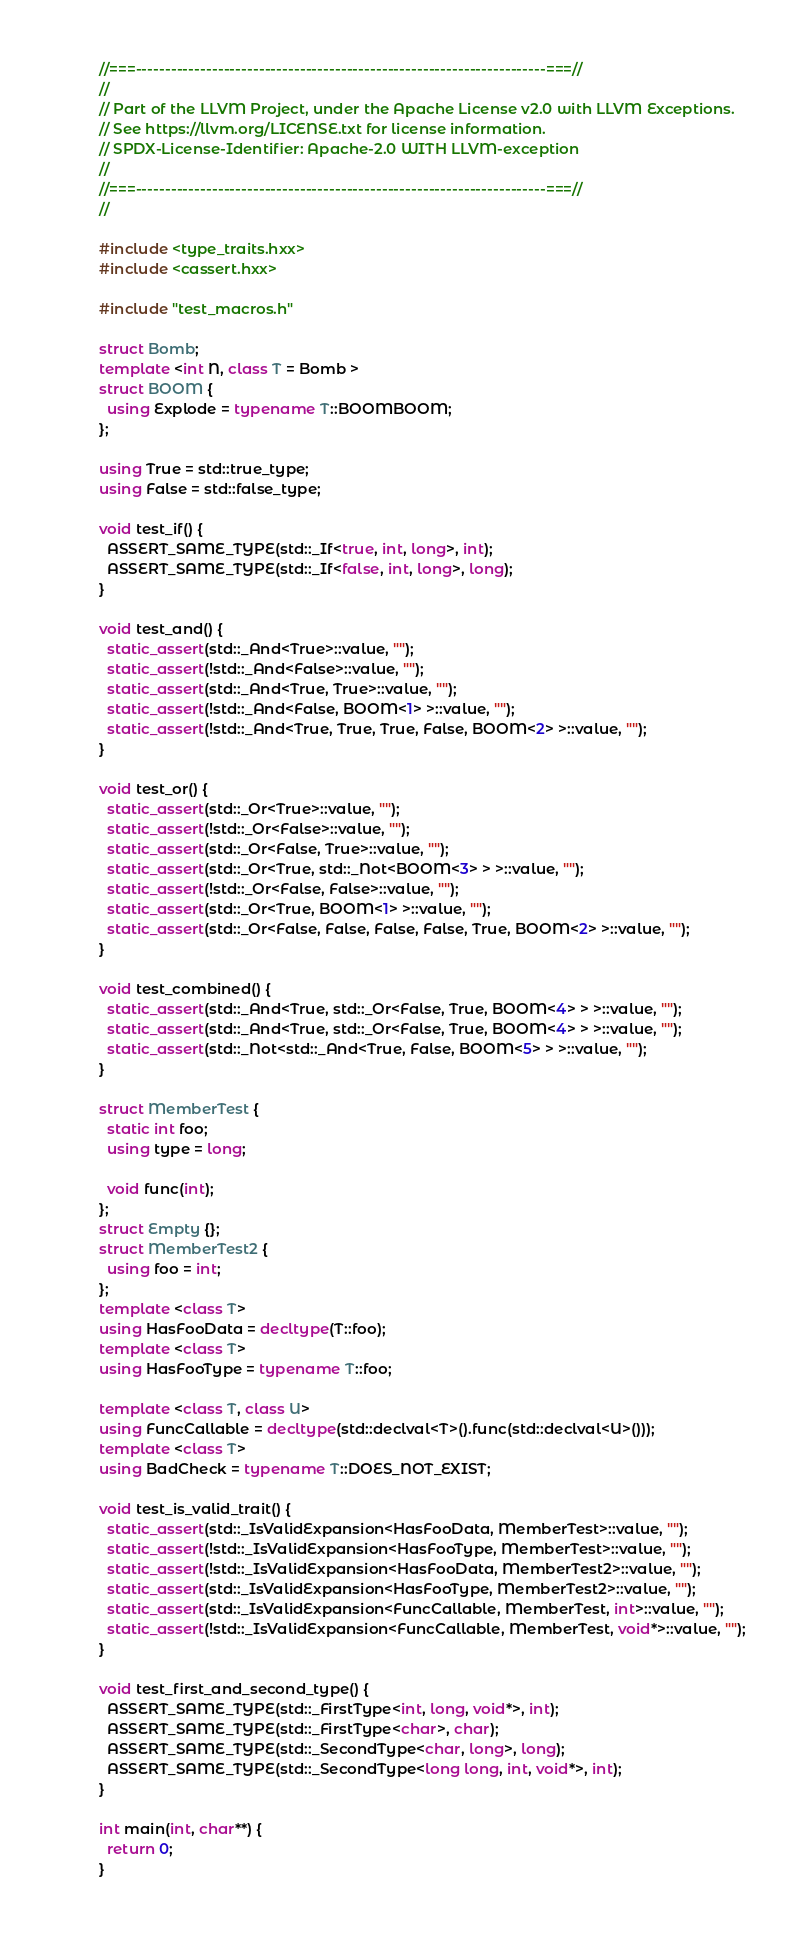<code> <loc_0><loc_0><loc_500><loc_500><_C++_>//===----------------------------------------------------------------------===//
//
// Part of the LLVM Project, under the Apache License v2.0 with LLVM Exceptions.
// See https://llvm.org/LICENSE.txt for license information.
// SPDX-License-Identifier: Apache-2.0 WITH LLVM-exception
//
//===----------------------------------------------------------------------===//
//

#include <type_traits.hxx>
#include <cassert.hxx>

#include "test_macros.h"

struct Bomb;
template <int N, class T = Bomb >
struct BOOM {
  using Explode = typename T::BOOMBOOM;
};

using True = std::true_type;
using False = std::false_type;

void test_if() {
  ASSERT_SAME_TYPE(std::_If<true, int, long>, int);
  ASSERT_SAME_TYPE(std::_If<false, int, long>, long);
}

void test_and() {
  static_assert(std::_And<True>::value, "");
  static_assert(!std::_And<False>::value, "");
  static_assert(std::_And<True, True>::value, "");
  static_assert(!std::_And<False, BOOM<1> >::value, "");
  static_assert(!std::_And<True, True, True, False, BOOM<2> >::value, "");
}

void test_or() {
  static_assert(std::_Or<True>::value, "");
  static_assert(!std::_Or<False>::value, "");
  static_assert(std::_Or<False, True>::value, "");
  static_assert(std::_Or<True, std::_Not<BOOM<3> > >::value, "");
  static_assert(!std::_Or<False, False>::value, "");
  static_assert(std::_Or<True, BOOM<1> >::value, "");
  static_assert(std::_Or<False, False, False, False, True, BOOM<2> >::value, "");
}

void test_combined() {
  static_assert(std::_And<True, std::_Or<False, True, BOOM<4> > >::value, "");
  static_assert(std::_And<True, std::_Or<False, True, BOOM<4> > >::value, "");
  static_assert(std::_Not<std::_And<True, False, BOOM<5> > >::value, "");
}

struct MemberTest {
  static int foo;
  using type = long;

  void func(int);
};
struct Empty {};
struct MemberTest2 {
  using foo = int;
};
template <class T>
using HasFooData = decltype(T::foo);
template <class T>
using HasFooType = typename T::foo;

template <class T, class U>
using FuncCallable = decltype(std::declval<T>().func(std::declval<U>()));
template <class T>
using BadCheck = typename T::DOES_NOT_EXIST;

void test_is_valid_trait() {
  static_assert(std::_IsValidExpansion<HasFooData, MemberTest>::value, "");
  static_assert(!std::_IsValidExpansion<HasFooType, MemberTest>::value, "");
  static_assert(!std::_IsValidExpansion<HasFooData, MemberTest2>::value, "");
  static_assert(std::_IsValidExpansion<HasFooType, MemberTest2>::value, "");
  static_assert(std::_IsValidExpansion<FuncCallable, MemberTest, int>::value, "");
  static_assert(!std::_IsValidExpansion<FuncCallable, MemberTest, void*>::value, "");
}

void test_first_and_second_type() {
  ASSERT_SAME_TYPE(std::_FirstType<int, long, void*>, int);
  ASSERT_SAME_TYPE(std::_FirstType<char>, char);
  ASSERT_SAME_TYPE(std::_SecondType<char, long>, long);
  ASSERT_SAME_TYPE(std::_SecondType<long long, int, void*>, int);
}

int main(int, char**) {
  return 0;
}
</code> 